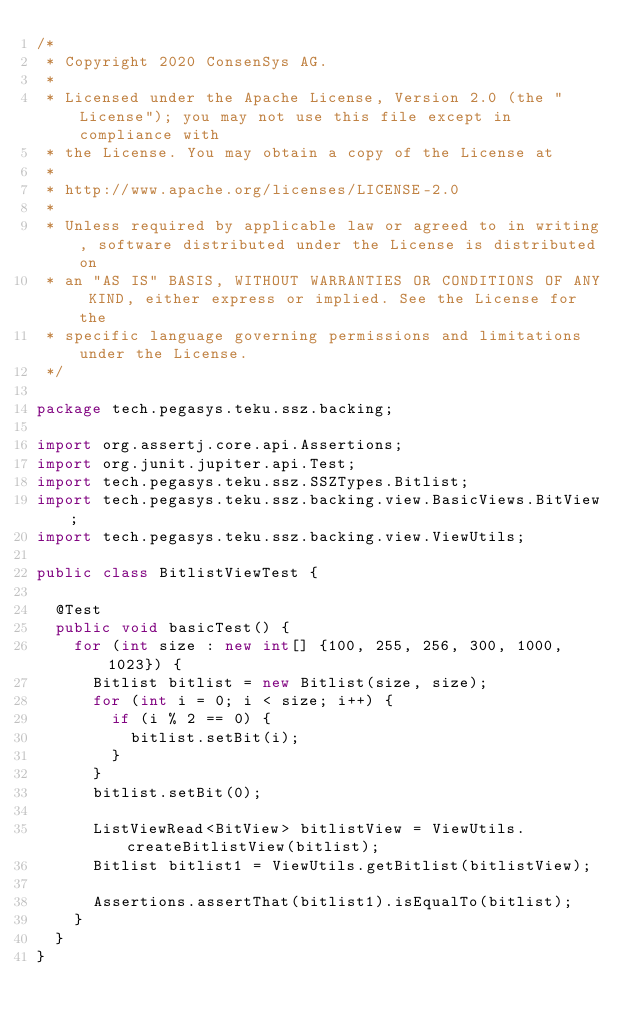Convert code to text. <code><loc_0><loc_0><loc_500><loc_500><_Java_>/*
 * Copyright 2020 ConsenSys AG.
 *
 * Licensed under the Apache License, Version 2.0 (the "License"); you may not use this file except in compliance with
 * the License. You may obtain a copy of the License at
 *
 * http://www.apache.org/licenses/LICENSE-2.0
 *
 * Unless required by applicable law or agreed to in writing, software distributed under the License is distributed on
 * an "AS IS" BASIS, WITHOUT WARRANTIES OR CONDITIONS OF ANY KIND, either express or implied. See the License for the
 * specific language governing permissions and limitations under the License.
 */

package tech.pegasys.teku.ssz.backing;

import org.assertj.core.api.Assertions;
import org.junit.jupiter.api.Test;
import tech.pegasys.teku.ssz.SSZTypes.Bitlist;
import tech.pegasys.teku.ssz.backing.view.BasicViews.BitView;
import tech.pegasys.teku.ssz.backing.view.ViewUtils;

public class BitlistViewTest {

  @Test
  public void basicTest() {
    for (int size : new int[] {100, 255, 256, 300, 1000, 1023}) {
      Bitlist bitlist = new Bitlist(size, size);
      for (int i = 0; i < size; i++) {
        if (i % 2 == 0) {
          bitlist.setBit(i);
        }
      }
      bitlist.setBit(0);

      ListViewRead<BitView> bitlistView = ViewUtils.createBitlistView(bitlist);
      Bitlist bitlist1 = ViewUtils.getBitlist(bitlistView);

      Assertions.assertThat(bitlist1).isEqualTo(bitlist);
    }
  }
}
</code> 